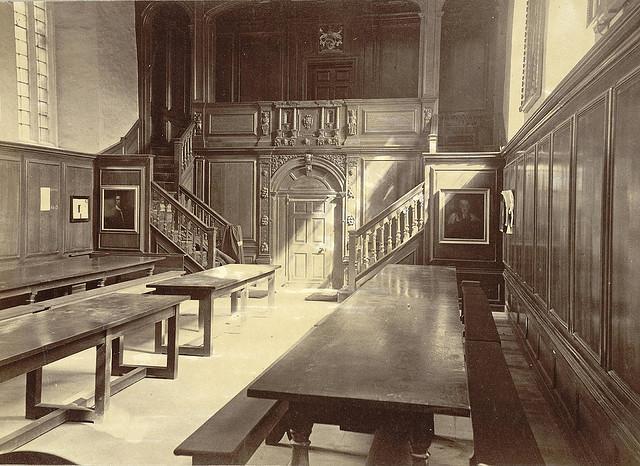How many dining tables are visible?
Give a very brief answer. 4. How many benches can be seen?
Give a very brief answer. 3. How many people could sleep in this bed?
Give a very brief answer. 0. 